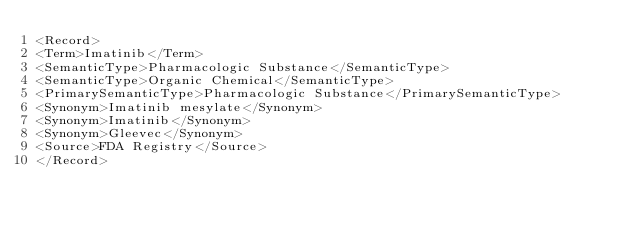<code> <loc_0><loc_0><loc_500><loc_500><_XML_><Record>
<Term>Imatinib</Term>
<SemanticType>Pharmacologic Substance</SemanticType>
<SemanticType>Organic Chemical</SemanticType>
<PrimarySemanticType>Pharmacologic Substance</PrimarySemanticType>
<Synonym>Imatinib mesylate</Synonym>
<Synonym>Imatinib</Synonym>
<Synonym>Gleevec</Synonym>
<Source>FDA Registry</Source>
</Record>
</code> 